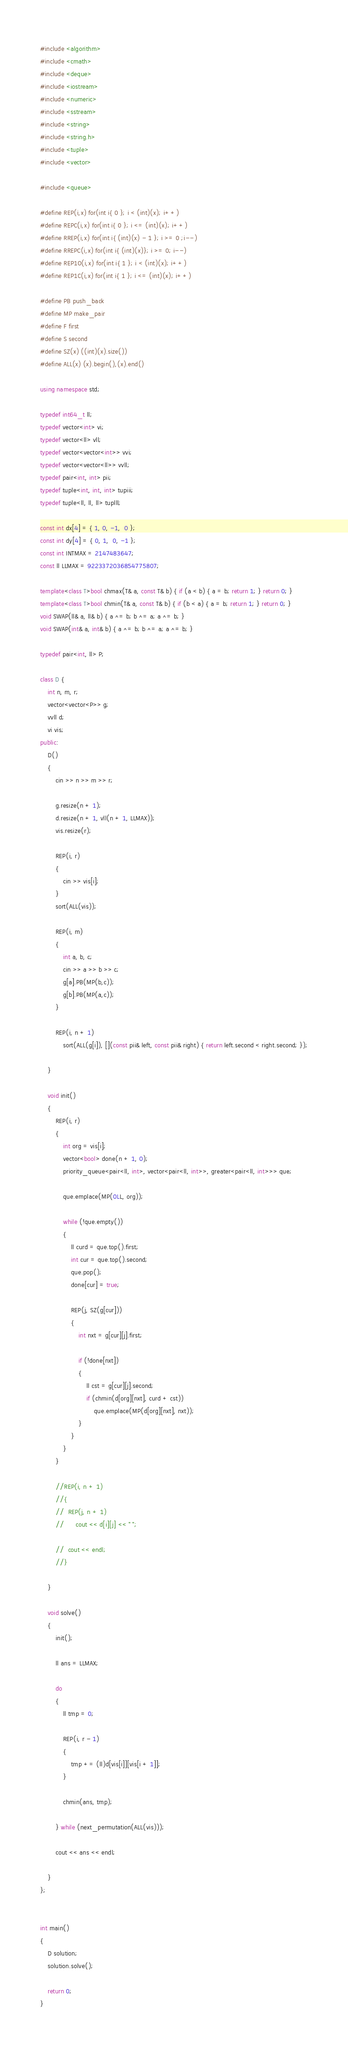<code> <loc_0><loc_0><loc_500><loc_500><_C++_>#include <algorithm>
#include <cmath>
#include <deque>
#include <iostream>
#include <numeric>
#include <sstream>
#include <string>
#include <string.h>
#include <tuple>
#include <vector>

#include <queue>

#define REP(i,x) for(int i{ 0 }; i < (int)(x); i++)
#define REPC(i,x) for(int i{ 0 }; i <= (int)(x); i++)
#define RREP(i,x) for(int i{ (int)(x) - 1 }; i >= 0 ;i--)
#define RREPC(i,x) for(int i{ (int)(x)}; i >= 0; i--)
#define REP1O(i,x) for(int i{ 1 }; i < (int)(x); i++)
#define REP1C(i,x) for(int i{ 1 }; i <= (int)(x); i++)

#define PB push_back
#define MP make_pair
#define F first
#define S second
#define SZ(x) ((int)(x).size())
#define ALL(x) (x).begin(),(x).end()

using namespace std;

typedef int64_t ll;
typedef vector<int> vi;
typedef vector<ll> vll;
typedef vector<vector<int>> vvi;
typedef vector<vector<ll>> vvll;
typedef pair<int, int> pii;
typedef tuple<int, int, int> tupiii;
typedef tuple<ll, ll, ll> tuplll;

const int dx[4] = { 1, 0, -1,  0 };
const int dy[4] = { 0, 1,  0, -1 };
const int INTMAX = 2147483647;
const ll LLMAX = 9223372036854775807;

template<class T>bool chmax(T& a, const T& b) { if (a < b) { a = b; return 1; } return 0; }
template<class T>bool chmin(T& a, const T& b) { if (b < a) { a = b; return 1; } return 0; }
void SWAP(ll& a, ll& b) { a ^= b; b ^= a; a ^= b; }
void SWAP(int& a, int& b) { a ^= b; b ^= a; a ^= b; }

typedef pair<int, ll> P;

class D {
	int n, m, r;
	vector<vector<P>> g;
	vvll d;
	vi vis;
public:
	D()
	{
		cin >> n >> m >> r;

		g.resize(n + 1);
		d.resize(n + 1, vll(n + 1, LLMAX));
		vis.resize(r);

		REP(i, r)
		{
			cin >> vis[i];
		}
		sort(ALL(vis));

		REP(i, m)
		{
			int a, b, c;
			cin >> a >> b >> c;
			g[a].PB(MP(b,c));
			g[b].PB(MP(a,c));
		}

		REP(i, n + 1)
			sort(ALL(g[i]), [](const pii& left, const pii& right) { return left.second < right.second; });

	}

	void init()
	{
		REP(i, r)
		{
			int org = vis[i];
			vector<bool> done(n + 1, 0);
			priority_queue<pair<ll, int>, vector<pair<ll, int>>, greater<pair<ll, int>>> que;

			que.emplace(MP(0LL, org));

			while (!que.empty())
			{
				ll curd = que.top().first;
				int cur = que.top().second;
				que.pop();
				done[cur] = true;

				REP(j, SZ(g[cur]))
				{
					int nxt = g[cur][j].first;

					if (!done[nxt])
					{
						ll cst = g[cur][j].second;
						if (chmin(d[org][nxt], curd + cst))
							que.emplace(MP(d[org][nxt], nxt));
					}
				}
			}
		}

		//REP(i, n + 1)
		//{
		//	REP(j, n + 1)
		//		cout << d[i][j] << " ";

		//	cout << endl;
		//}

	}

	void solve()
	{
		init();

		ll ans = LLMAX;

		do
		{
			ll tmp = 0;

			REP(i, r - 1)
			{
				tmp += (ll)d[vis[i]][vis[i + 1]];
			}
			
			chmin(ans, tmp);

		} while (next_permutation(ALL(vis)));

		cout << ans << endl;

	}
};


int main()
{
	D solution;
	solution.solve();

	return 0;
}</code> 